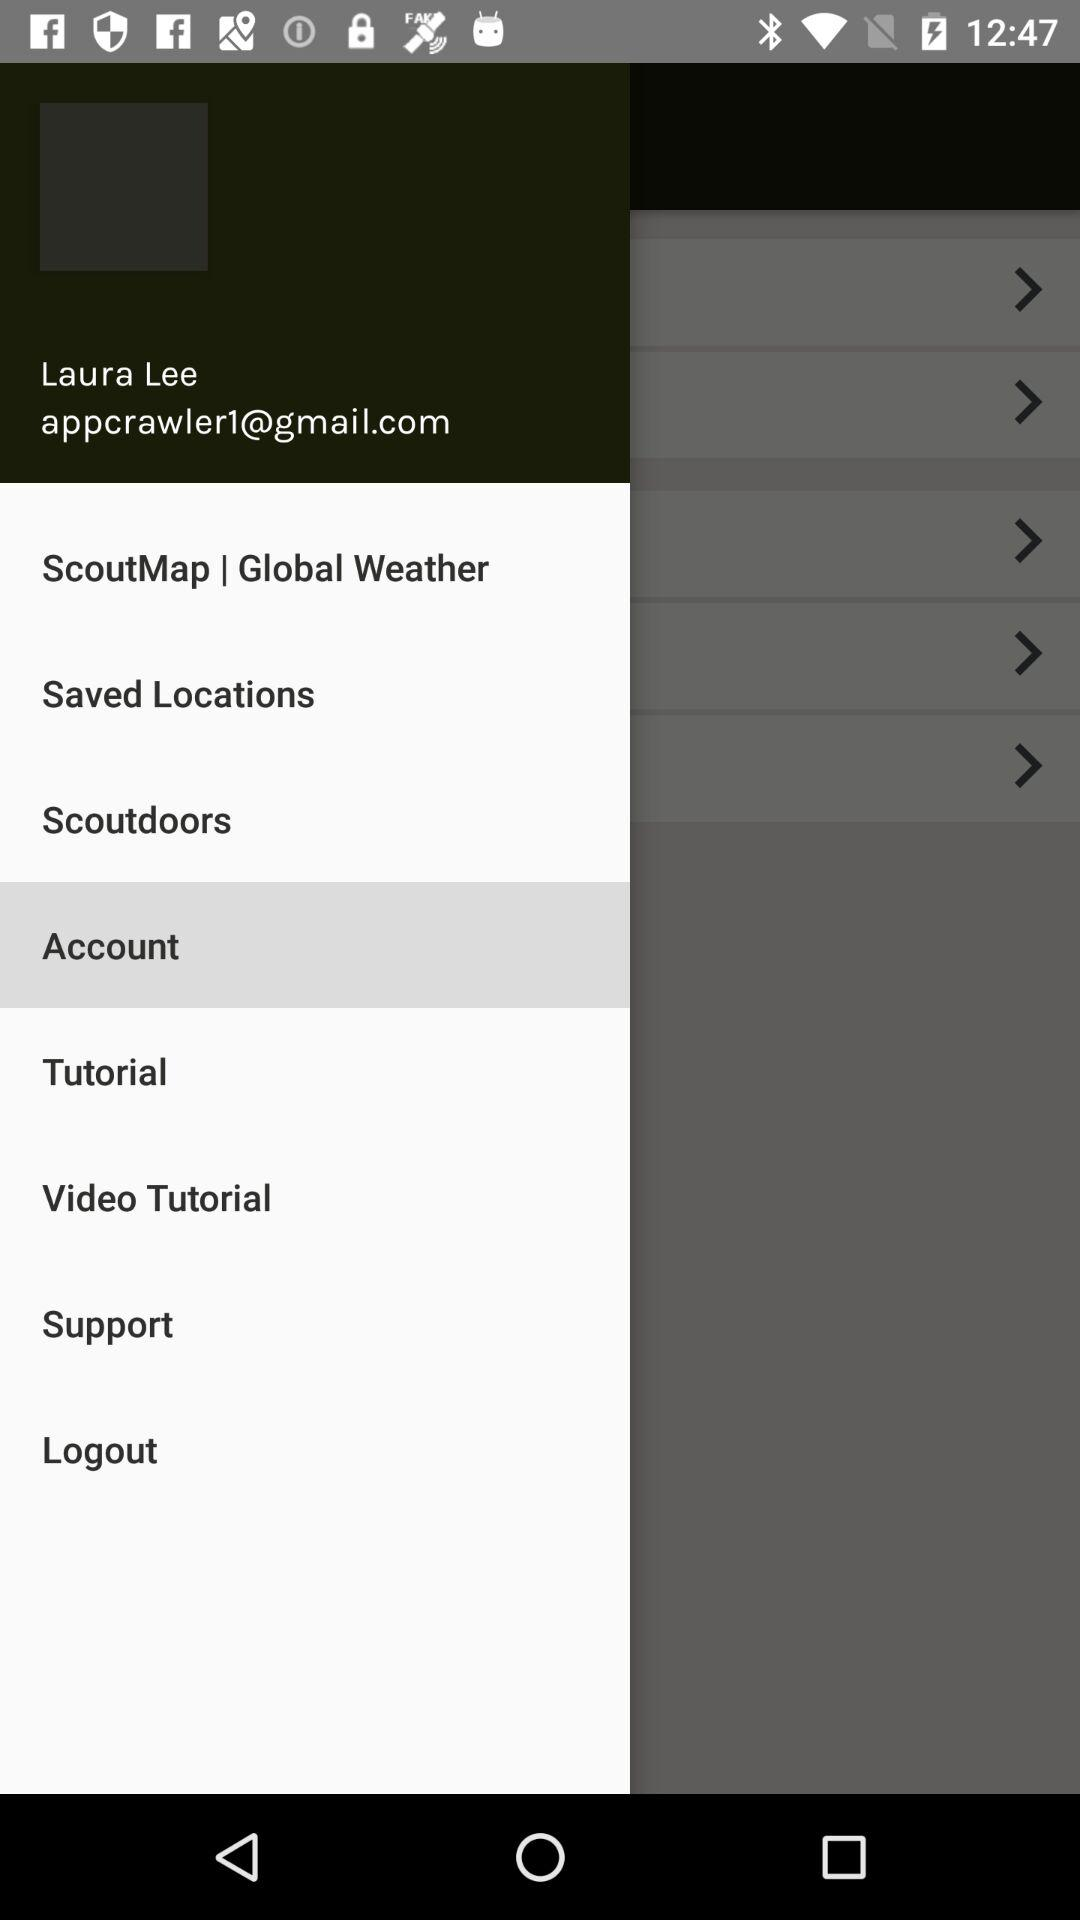What is the email address? The email address is appcrawler1@gmail.com. 